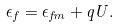Convert formula to latex. <formula><loc_0><loc_0><loc_500><loc_500>\epsilon _ { f } = \epsilon _ { f m } + q U .</formula> 